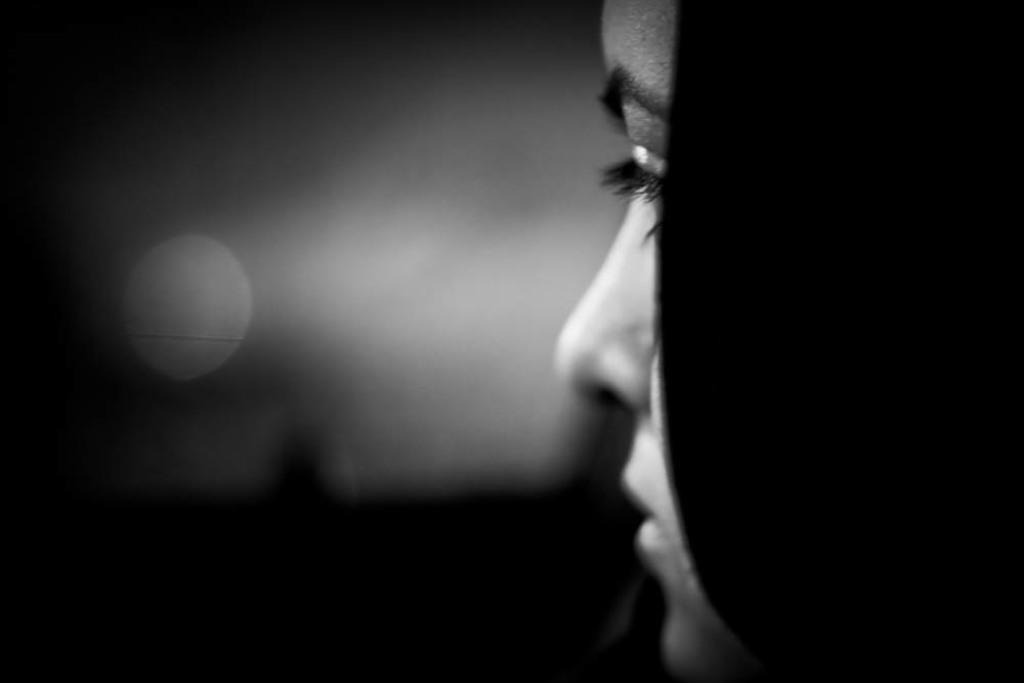What is the color scheme of the image? The image is black and white. Can you describe the main subject of the image? There is a girl in the image. What type of fish can be seen swimming in the image? There are no fish present in the image; it is a black and white image featuring a girl. What type of secretary is shown working in the image? There is no secretary present in the image; it features a girl. 